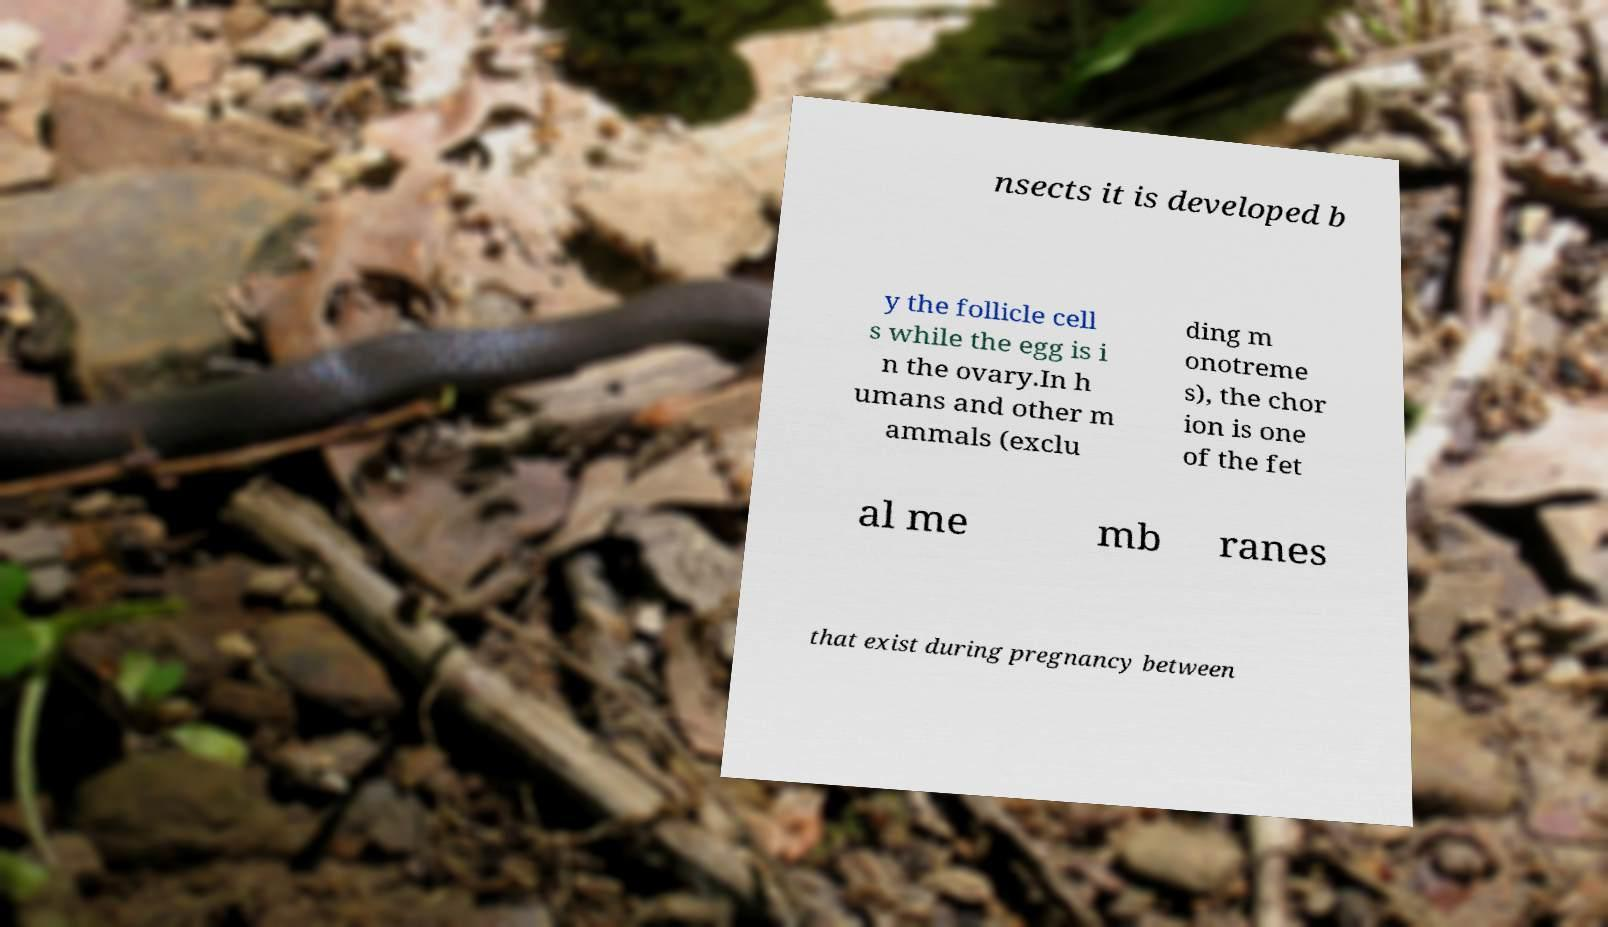There's text embedded in this image that I need extracted. Can you transcribe it verbatim? nsects it is developed b y the follicle cell s while the egg is i n the ovary.In h umans and other m ammals (exclu ding m onotreme s), the chor ion is one of the fet al me mb ranes that exist during pregnancy between 